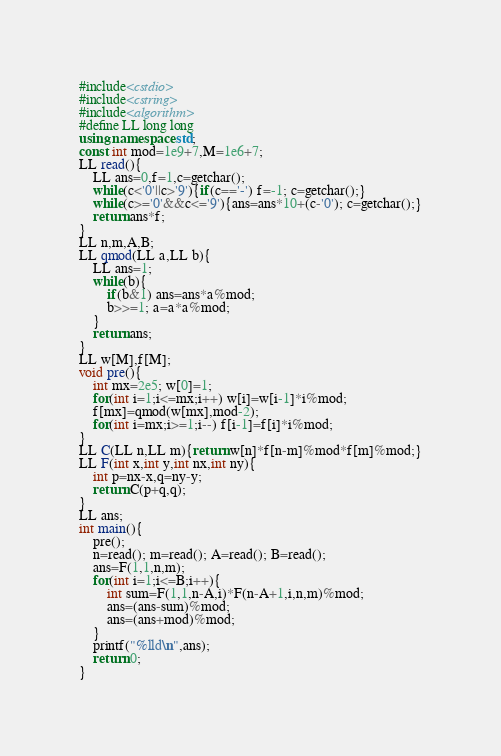Convert code to text. <code><loc_0><loc_0><loc_500><loc_500><_C++_>#include<cstdio>
#include<cstring>
#include<algorithm>
#define LL long long
using namespace std;
const int mod=1e9+7,M=1e6+7;
LL read(){
	LL ans=0,f=1,c=getchar();
	while(c<'0'||c>'9'){if(c=='-') f=-1; c=getchar();}
	while(c>='0'&&c<='9'){ans=ans*10+(c-'0'); c=getchar();}
	return ans*f;
}
LL n,m,A,B;
LL qmod(LL a,LL b){
	LL ans=1;
	while(b){
		if(b&1) ans=ans*a%mod;
		b>>=1; a=a*a%mod;
	}
	return ans;
}
LL w[M],f[M];
void pre(){
	int mx=2e5; w[0]=1;
	for(int i=1;i<=mx;i++) w[i]=w[i-1]*i%mod;
	f[mx]=qmod(w[mx],mod-2);
	for(int i=mx;i>=1;i--) f[i-1]=f[i]*i%mod;
} 
LL C(LL n,LL m){return w[n]*f[n-m]%mod*f[m]%mod;}
LL F(int x,int y,int nx,int ny){
	int p=nx-x,q=ny-y;
	return C(p+q,q);
}
LL ans;
int main(){
	pre();
	n=read(); m=read(); A=read(); B=read();
	ans=F(1,1,n,m);
	for(int i=1;i<=B;i++){
		int sum=F(1,1,n-A,i)*F(n-A+1,i,n,m)%mod;
		ans=(ans-sum)%mod;
		ans=(ans+mod)%mod;
	}
	printf("%lld\n",ans);
	return 0;
}</code> 